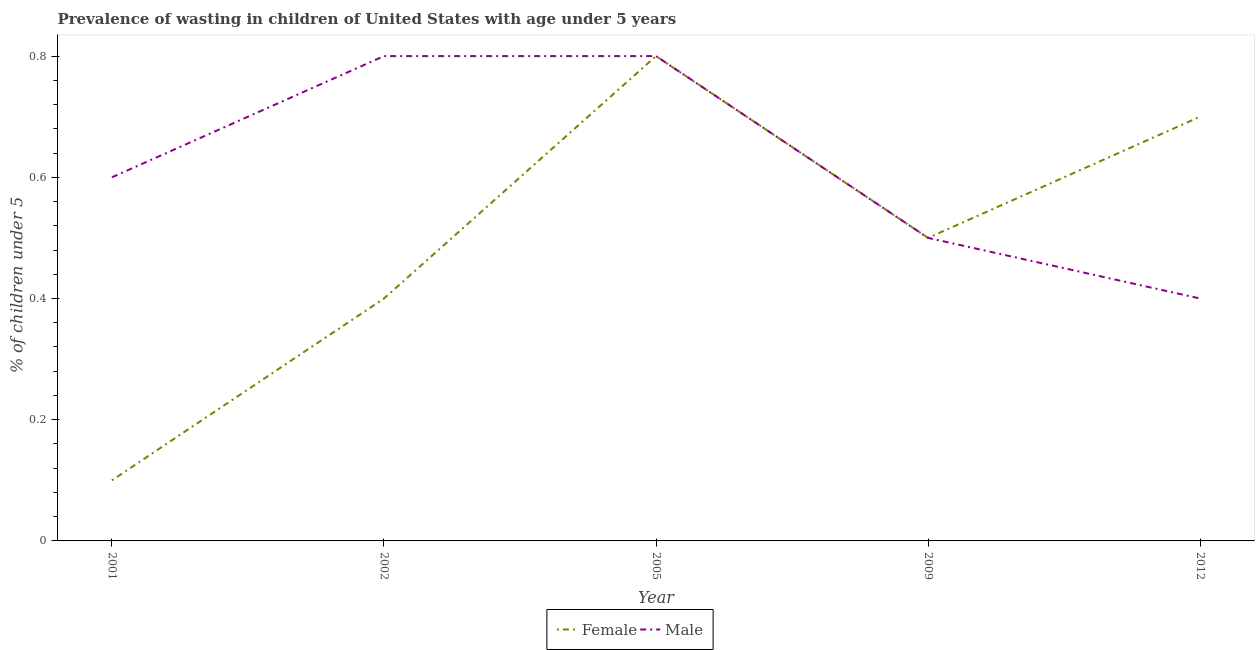How many different coloured lines are there?
Your answer should be very brief. 2. What is the percentage of undernourished female children in 2001?
Provide a short and direct response. 0.1. Across all years, what is the maximum percentage of undernourished female children?
Make the answer very short. 0.8. Across all years, what is the minimum percentage of undernourished female children?
Your response must be concise. 0.1. What is the total percentage of undernourished female children in the graph?
Offer a very short reply. 2.5. What is the difference between the percentage of undernourished male children in 2001 and that in 2009?
Offer a very short reply. 0.1. What is the difference between the percentage of undernourished female children in 2009 and the percentage of undernourished male children in 2002?
Your answer should be compact. -0.3. What is the average percentage of undernourished female children per year?
Provide a short and direct response. 0.5. In the year 2012, what is the difference between the percentage of undernourished female children and percentage of undernourished male children?
Your response must be concise. 0.3. In how many years, is the percentage of undernourished male children greater than 0.7600000000000001 %?
Give a very brief answer. 2. What is the ratio of the percentage of undernourished male children in 2001 to that in 2005?
Your response must be concise. 0.75. What is the difference between the highest and the second highest percentage of undernourished male children?
Offer a very short reply. 0. What is the difference between the highest and the lowest percentage of undernourished female children?
Offer a terse response. 0.7. Is the percentage of undernourished male children strictly greater than the percentage of undernourished female children over the years?
Offer a terse response. No. Where does the legend appear in the graph?
Provide a short and direct response. Bottom center. What is the title of the graph?
Keep it short and to the point. Prevalence of wasting in children of United States with age under 5 years. Does "RDB concessional" appear as one of the legend labels in the graph?
Your answer should be compact. No. What is the label or title of the X-axis?
Make the answer very short. Year. What is the label or title of the Y-axis?
Offer a terse response.  % of children under 5. What is the  % of children under 5 of Female in 2001?
Make the answer very short. 0.1. What is the  % of children under 5 of Male in 2001?
Offer a very short reply. 0.6. What is the  % of children under 5 in Female in 2002?
Provide a succinct answer. 0.4. What is the  % of children under 5 of Male in 2002?
Give a very brief answer. 0.8. What is the  % of children under 5 in Female in 2005?
Offer a terse response. 0.8. What is the  % of children under 5 in Male in 2005?
Give a very brief answer. 0.8. What is the  % of children under 5 of Female in 2009?
Your answer should be compact. 0.5. What is the  % of children under 5 in Male in 2009?
Your answer should be compact. 0.5. What is the  % of children under 5 in Female in 2012?
Ensure brevity in your answer.  0.7. What is the  % of children under 5 of Male in 2012?
Give a very brief answer. 0.4. Across all years, what is the maximum  % of children under 5 of Female?
Keep it short and to the point. 0.8. Across all years, what is the maximum  % of children under 5 of Male?
Your answer should be very brief. 0.8. Across all years, what is the minimum  % of children under 5 in Female?
Provide a succinct answer. 0.1. Across all years, what is the minimum  % of children under 5 in Male?
Your answer should be compact. 0.4. What is the total  % of children under 5 in Male in the graph?
Offer a terse response. 3.1. What is the difference between the  % of children under 5 of Female in 2001 and that in 2005?
Your answer should be compact. -0.7. What is the difference between the  % of children under 5 of Male in 2001 and that in 2005?
Make the answer very short. -0.2. What is the difference between the  % of children under 5 of Female in 2001 and that in 2009?
Ensure brevity in your answer.  -0.4. What is the difference between the  % of children under 5 in Male in 2001 and that in 2009?
Make the answer very short. 0.1. What is the difference between the  % of children under 5 of Female in 2001 and that in 2012?
Make the answer very short. -0.6. What is the difference between the  % of children under 5 in Male in 2002 and that in 2005?
Offer a very short reply. 0. What is the difference between the  % of children under 5 in Female in 2002 and that in 2009?
Keep it short and to the point. -0.1. What is the difference between the  % of children under 5 in Male in 2002 and that in 2009?
Ensure brevity in your answer.  0.3. What is the difference between the  % of children under 5 in Female in 2002 and that in 2012?
Ensure brevity in your answer.  -0.3. What is the difference between the  % of children under 5 in Female in 2005 and that in 2009?
Ensure brevity in your answer.  0.3. What is the difference between the  % of children under 5 of Male in 2009 and that in 2012?
Provide a short and direct response. 0.1. What is the difference between the  % of children under 5 of Female in 2001 and the  % of children under 5 of Male in 2009?
Give a very brief answer. -0.4. What is the difference between the  % of children under 5 in Female in 2001 and the  % of children under 5 in Male in 2012?
Provide a succinct answer. -0.3. What is the difference between the  % of children under 5 in Female in 2002 and the  % of children under 5 in Male in 2009?
Your answer should be very brief. -0.1. What is the difference between the  % of children under 5 in Female in 2005 and the  % of children under 5 in Male in 2009?
Keep it short and to the point. 0.3. What is the difference between the  % of children under 5 in Female in 2005 and the  % of children under 5 in Male in 2012?
Your response must be concise. 0.4. What is the average  % of children under 5 in Male per year?
Your answer should be compact. 0.62. In the year 2001, what is the difference between the  % of children under 5 of Female and  % of children under 5 of Male?
Provide a short and direct response. -0.5. In the year 2005, what is the difference between the  % of children under 5 of Female and  % of children under 5 of Male?
Ensure brevity in your answer.  0. In the year 2009, what is the difference between the  % of children under 5 in Female and  % of children under 5 in Male?
Your answer should be very brief. 0. In the year 2012, what is the difference between the  % of children under 5 of Female and  % of children under 5 of Male?
Provide a succinct answer. 0.3. What is the ratio of the  % of children under 5 of Male in 2001 to that in 2005?
Ensure brevity in your answer.  0.75. What is the ratio of the  % of children under 5 in Female in 2001 to that in 2012?
Provide a short and direct response. 0.14. What is the ratio of the  % of children under 5 of Female in 2002 to that in 2005?
Your answer should be very brief. 0.5. What is the ratio of the  % of children under 5 in Male in 2002 to that in 2005?
Keep it short and to the point. 1. What is the ratio of the  % of children under 5 of Male in 2002 to that in 2009?
Offer a very short reply. 1.6. What is the ratio of the  % of children under 5 in Female in 2005 to that in 2009?
Ensure brevity in your answer.  1.6. What is the ratio of the  % of children under 5 in Male in 2005 to that in 2009?
Your answer should be very brief. 1.6. What is the ratio of the  % of children under 5 of Female in 2009 to that in 2012?
Offer a terse response. 0.71. What is the ratio of the  % of children under 5 of Male in 2009 to that in 2012?
Your answer should be compact. 1.25. What is the difference between the highest and the second highest  % of children under 5 in Female?
Provide a succinct answer. 0.1. 